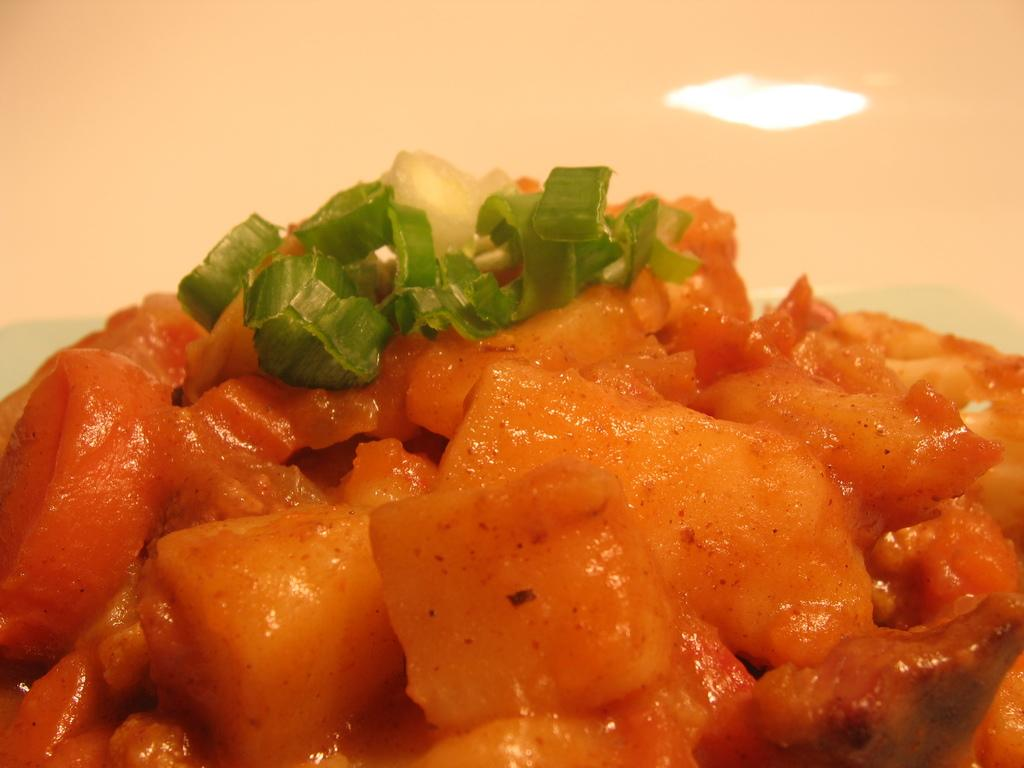What is the focus of the image? The image is zoomed in, so the focus is on a specific detail. What can be seen in the foreground of the image? There is a food item in the foreground of the image. What is visible in the background of the image? There is a light in the background of the image. What type of war is being depicted in the image? There is no depiction of war in the image; it features a food item in the foreground and a light in the background. What kind of wool can be seen in the image? There is no wool present in the image. 